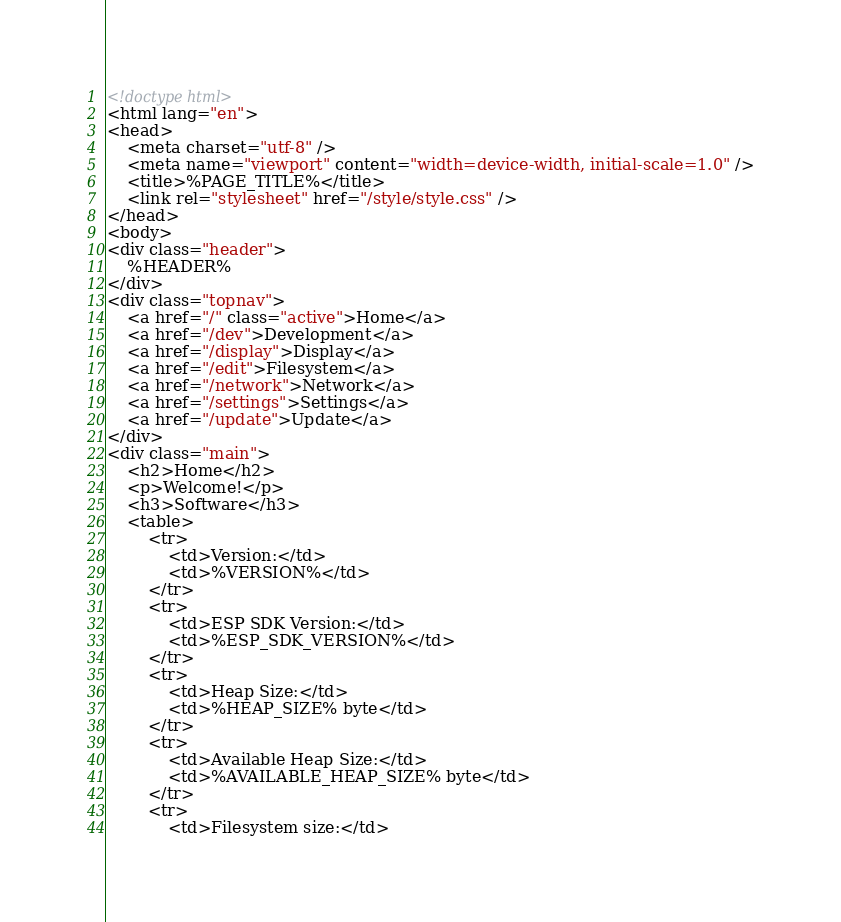<code> <loc_0><loc_0><loc_500><loc_500><_HTML_><!doctype html>
<html lang="en">
<head>
    <meta charset="utf-8" />
    <meta name="viewport" content="width=device-width, initial-scale=1.0" />
    <title>%PAGE_TITLE%</title>
    <link rel="stylesheet" href="/style/style.css" />
</head>
<body>
<div class="header">
    %HEADER%
</div>
<div class="topnav">
    <a href="/" class="active">Home</a>
    <a href="/dev">Development</a>
    <a href="/display">Display</a>
    <a href="/edit">Filesystem</a>
    <a href="/network">Network</a>
    <a href="/settings">Settings</a>
    <a href="/update">Update</a>
</div>
<div class="main">
    <h2>Home</h2>
    <p>Welcome!</p>
    <h3>Software</h3>
    <table>
        <tr>
            <td>Version:</td>
            <td>%VERSION%</td>
        </tr>
        <tr>
            <td>ESP SDK Version:</td>
            <td>%ESP_SDK_VERSION%</td>
        </tr>
        <tr>
            <td>Heap Size:</td>
            <td>%HEAP_SIZE% byte</td>
        </tr>
        <tr>
            <td>Available Heap Size:</td>
            <td>%AVAILABLE_HEAP_SIZE% byte</td>
        </tr>
        <tr>
            <td>Filesystem size:</td></code> 